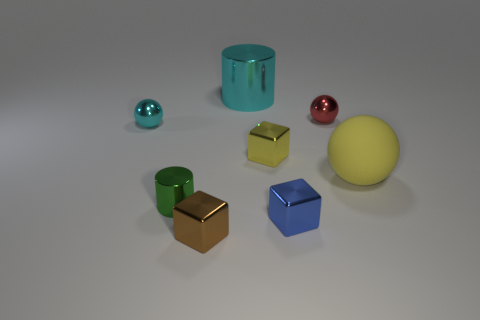How many other things are the same material as the yellow cube?
Give a very brief answer. 6. What color is the small sphere left of the metallic cylinder that is in front of the big rubber ball?
Ensure brevity in your answer.  Cyan. How many large metal objects have the same color as the large sphere?
Offer a terse response. 0. There is a big metal cylinder; is it the same color as the small metallic cube behind the large yellow sphere?
Provide a short and direct response. No. Are there fewer blue things than small green shiny cubes?
Provide a succinct answer. No. Is the number of tiny blue blocks to the left of the large metallic thing greater than the number of metal cubes that are behind the large yellow rubber object?
Your answer should be very brief. No. Is the cyan sphere made of the same material as the small blue object?
Offer a very short reply. Yes. There is a metal block that is on the left side of the small yellow thing; how many metal balls are in front of it?
Keep it short and to the point. 0. There is a ball behind the cyan sphere; does it have the same color as the large ball?
Provide a short and direct response. No. How many objects are either red objects or metal balls that are left of the tiny blue metallic block?
Your answer should be compact. 2. 